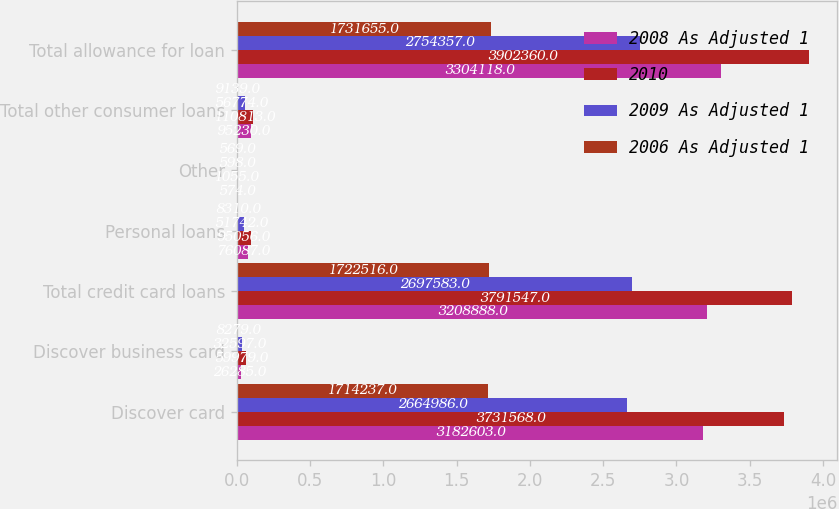Convert chart. <chart><loc_0><loc_0><loc_500><loc_500><stacked_bar_chart><ecel><fcel>Discover card<fcel>Discover business card<fcel>Total credit card loans<fcel>Personal loans<fcel>Other<fcel>Total other consumer loans<fcel>Total allowance for loan<nl><fcel>2008 As Adjusted 1<fcel>3.1826e+06<fcel>26285<fcel>3.20889e+06<fcel>76087<fcel>574<fcel>95230<fcel>3.30412e+06<nl><fcel>2010<fcel>3.73157e+06<fcel>59979<fcel>3.79155e+06<fcel>95056<fcel>1055<fcel>110813<fcel>3.90236e+06<nl><fcel>2009 As Adjusted 1<fcel>2.66499e+06<fcel>32597<fcel>2.69758e+06<fcel>51742<fcel>598<fcel>56774<fcel>2.75436e+06<nl><fcel>2006 As Adjusted 1<fcel>1.71424e+06<fcel>8279<fcel>1.72252e+06<fcel>8310<fcel>569<fcel>9139<fcel>1.73166e+06<nl></chart> 